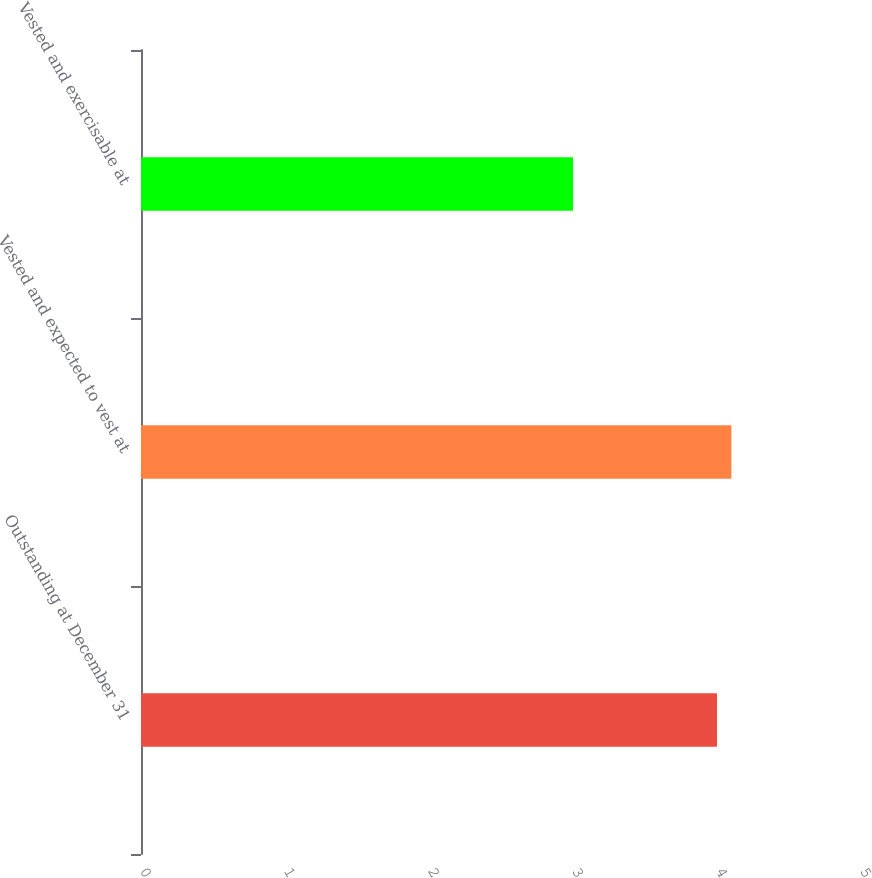<chart> <loc_0><loc_0><loc_500><loc_500><bar_chart><fcel>Outstanding at December 31<fcel>Vested and expected to vest at<fcel>Vested and exercisable at<nl><fcel>4<fcel>4.1<fcel>3<nl></chart> 